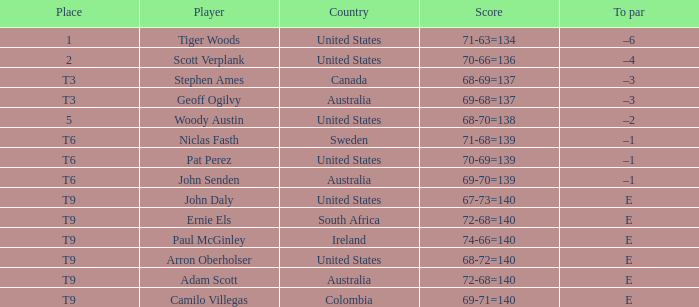What country does adam scott hail from? Australia. 